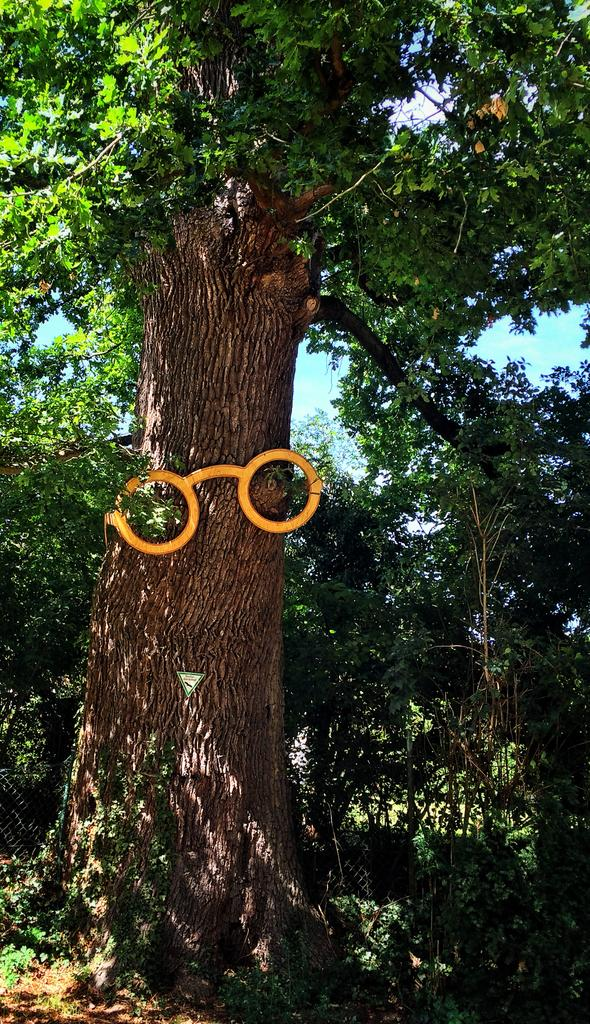What type of vegetation can be seen in the image? There are trees in the image. What is the color of the trees in the image? The trees are green in color. What else is visible in the image besides the trees? The sky is visible in the image. What is the color of the sky in the image? The sky is blue in color. How many cakes are hanging from the trees in the image? There are no cakes present in the image; it features trees and a blue sky. What type of tail can be seen on the trees in the image? There are no tails present in the image; it features trees and a blue sky. 